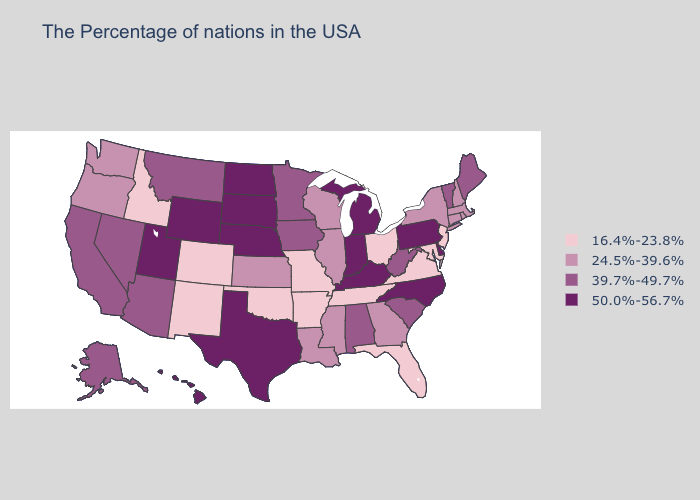Name the states that have a value in the range 39.7%-49.7%?
Be succinct. Maine, Vermont, South Carolina, West Virginia, Alabama, Minnesota, Iowa, Montana, Arizona, Nevada, California, Alaska. Name the states that have a value in the range 16.4%-23.8%?
Answer briefly. New Jersey, Maryland, Virginia, Ohio, Florida, Tennessee, Missouri, Arkansas, Oklahoma, Colorado, New Mexico, Idaho. What is the lowest value in states that border Tennessee?
Concise answer only. 16.4%-23.8%. Among the states that border Kansas , does Nebraska have the highest value?
Quick response, please. Yes. Does Minnesota have the lowest value in the MidWest?
Give a very brief answer. No. What is the value of Utah?
Give a very brief answer. 50.0%-56.7%. How many symbols are there in the legend?
Concise answer only. 4. Which states have the lowest value in the USA?
Concise answer only. New Jersey, Maryland, Virginia, Ohio, Florida, Tennessee, Missouri, Arkansas, Oklahoma, Colorado, New Mexico, Idaho. Among the states that border Illinois , does Wisconsin have the highest value?
Give a very brief answer. No. What is the value of North Carolina?
Short answer required. 50.0%-56.7%. Among the states that border Texas , does Louisiana have the lowest value?
Concise answer only. No. Does Tennessee have a lower value than North Carolina?
Concise answer only. Yes. What is the value of Pennsylvania?
Concise answer only. 50.0%-56.7%. Does North Dakota have the highest value in the MidWest?
Answer briefly. Yes. Which states have the lowest value in the Northeast?
Write a very short answer. New Jersey. 